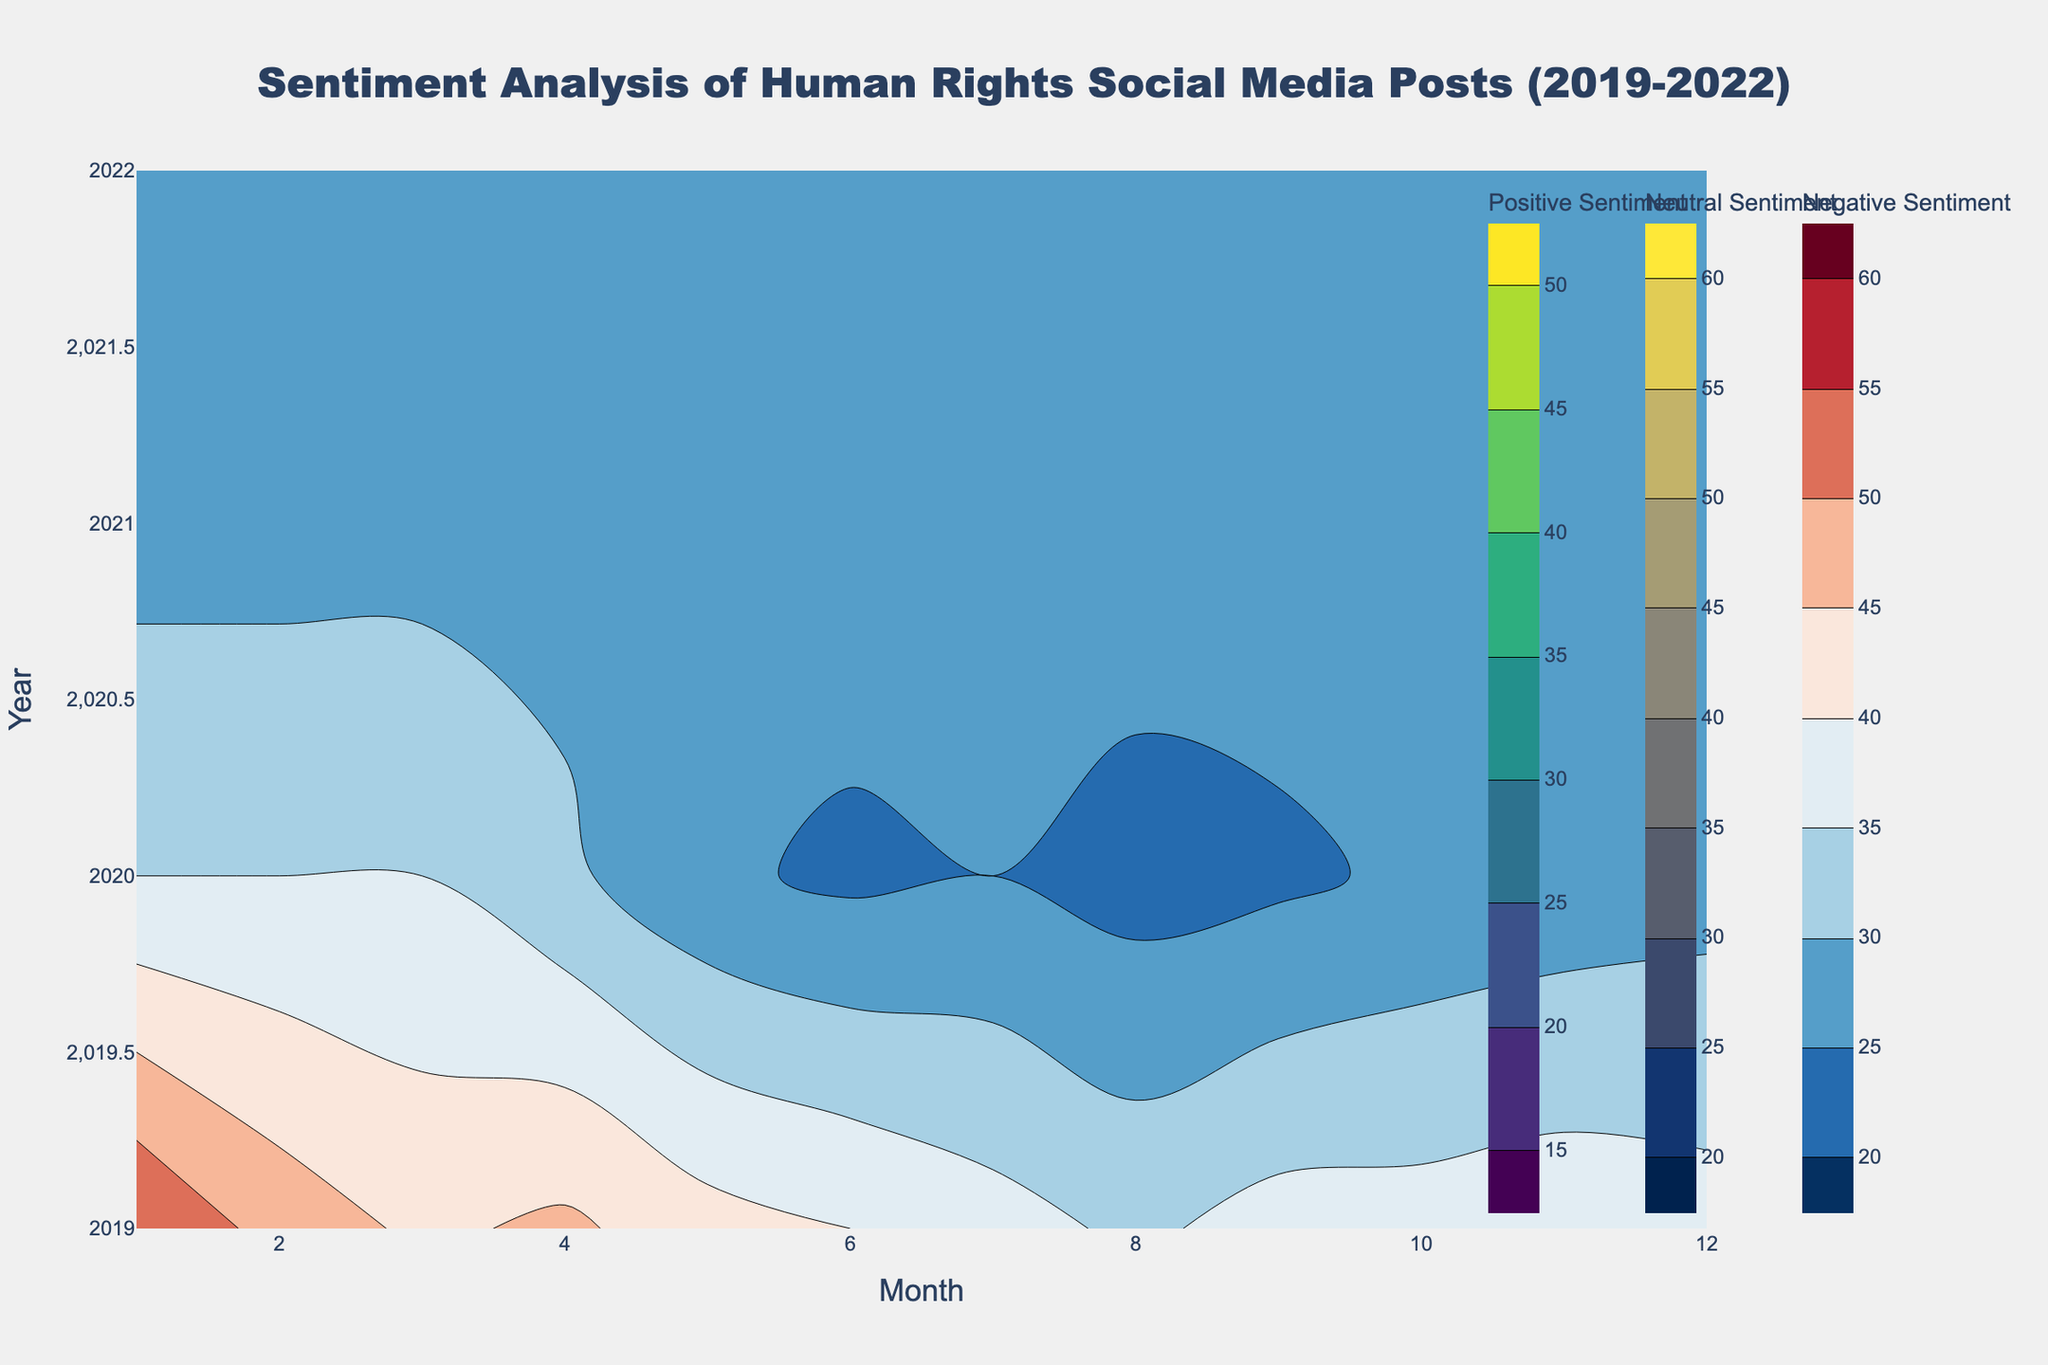What is the title of the figure? The title is usually found at the top of the figure which gives an overview of what the data represents. Here, it should be clearly visible.
Answer: Sentiment Analysis of Human Rights Social Media Posts (2019-2022) What do the x-axis and y-axis represent in the figure? The x-axis and y-axis typically label the dimensions of the data shown. In this figure, the x-axis represents the month and the y-axis represents the year.
Answer: x-axis: Month, y-axis: Year What color scale is used for depicting positive sentiment? The color scale for each sentiment type is indicated in the contour trace descriptions. For positive sentiment, 'Viridis' color scale is used.
Answer: Viridis In which month and year did positive sentiment reach its highest level? By observing the positive sentiment contour plot, we look for the highest contour value or the brightest color. The positive sentiment reached its maximum near June 2020.
Answer: June 2020 How does the neutral sentiment change over the years from January 2019 to December 2022? By observing the neutral sentiment contour plot, identify the color trends across years. The neutral sentiment starts high and gradually increases except for minor dips.
Answer: Gradually increases Compare the neutral sentiment in January 2020 and January 2021. Which was higher? By comparing the contour lines for neutral sentiment in January 2020 and January 2021, see which has a higher value. January 2021 shows a higher neutral sentiment than January 2020.
Answer: January 2021 What is the difference in positive sentiment between December 2019 and December 2022? Identify the contour values for positive sentiment in December 2019 and December 2022 and calculate the difference, subtracting the 2019 value from the 2022 value. December 2019 has a positive sentiment of 35 while December 2022 has 22, so the difference is 35 - 22.
Answer: 13 During which period did the negative sentiment show the most significant decline? Identify the steepest decline in contour values for negative sentiment across years. There is a noticeable decline in negative sentiment during the transition from 2019 to 2020.
Answer: 2019 to 2020 What does a 'contour' in this plot represent? Each contour line represents specific sentiment values across different months and years, depicting areas of equal value on the chart.
Answer: Specific sentiment values How does positive sentiment in July 2019 compare to July 2021? Observe the contour values for positive sentiment in July 2019 and July 2021. Positive sentiment in July 2019 is higher than in July 2021.
Answer: July 2019 higher 